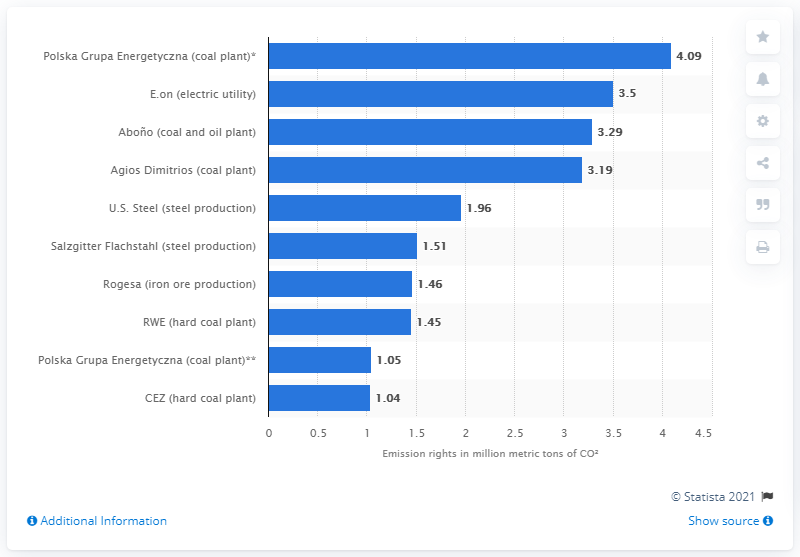Mention a couple of crucial points in this snapshot. In 2010, Polska Energetyczna purchased 4.09 tonnes of CO2 carbon credits. 